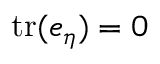<formula> <loc_0><loc_0><loc_500><loc_500>t r ( e _ { \eta } ) = 0</formula> 